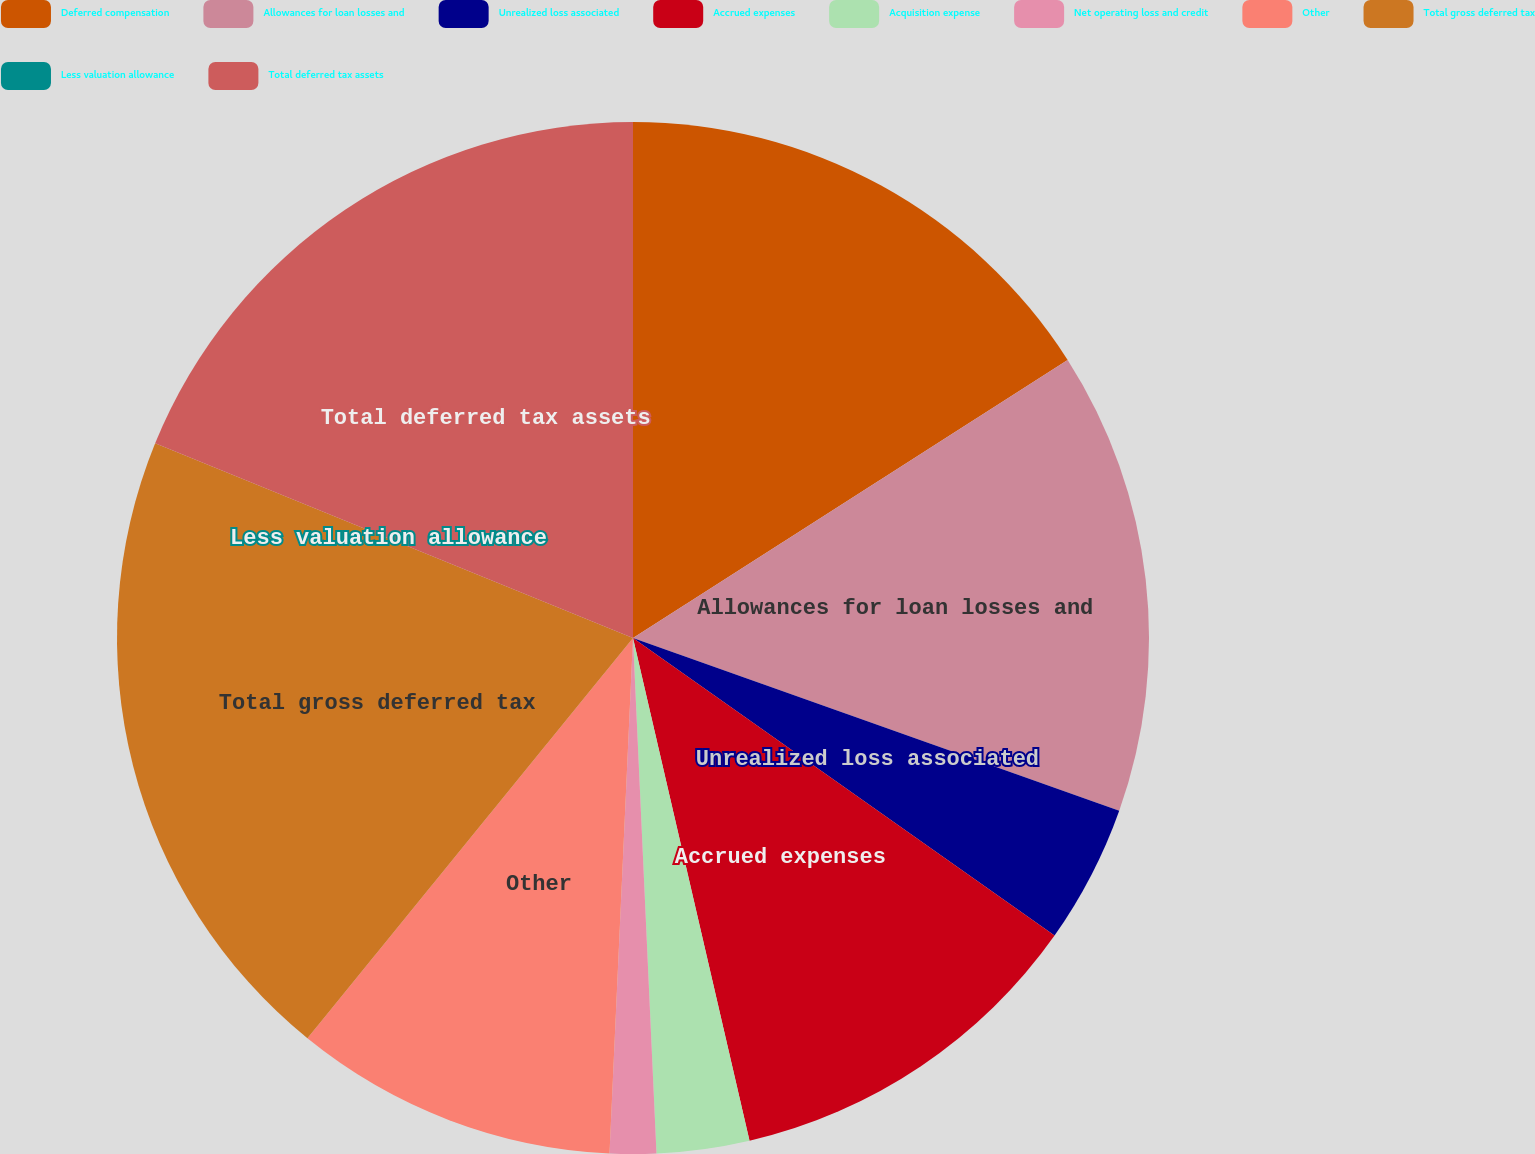<chart> <loc_0><loc_0><loc_500><loc_500><pie_chart><fcel>Deferred compensation<fcel>Allowances for loan losses and<fcel>Unrealized loss associated<fcel>Accrued expenses<fcel>Acquisition expense<fcel>Net operating loss and credit<fcel>Other<fcel>Total gross deferred tax<fcel>Less valuation allowance<fcel>Total deferred tax assets<nl><fcel>15.94%<fcel>14.49%<fcel>4.35%<fcel>11.59%<fcel>2.9%<fcel>1.45%<fcel>10.14%<fcel>20.29%<fcel>0.0%<fcel>18.84%<nl></chart> 